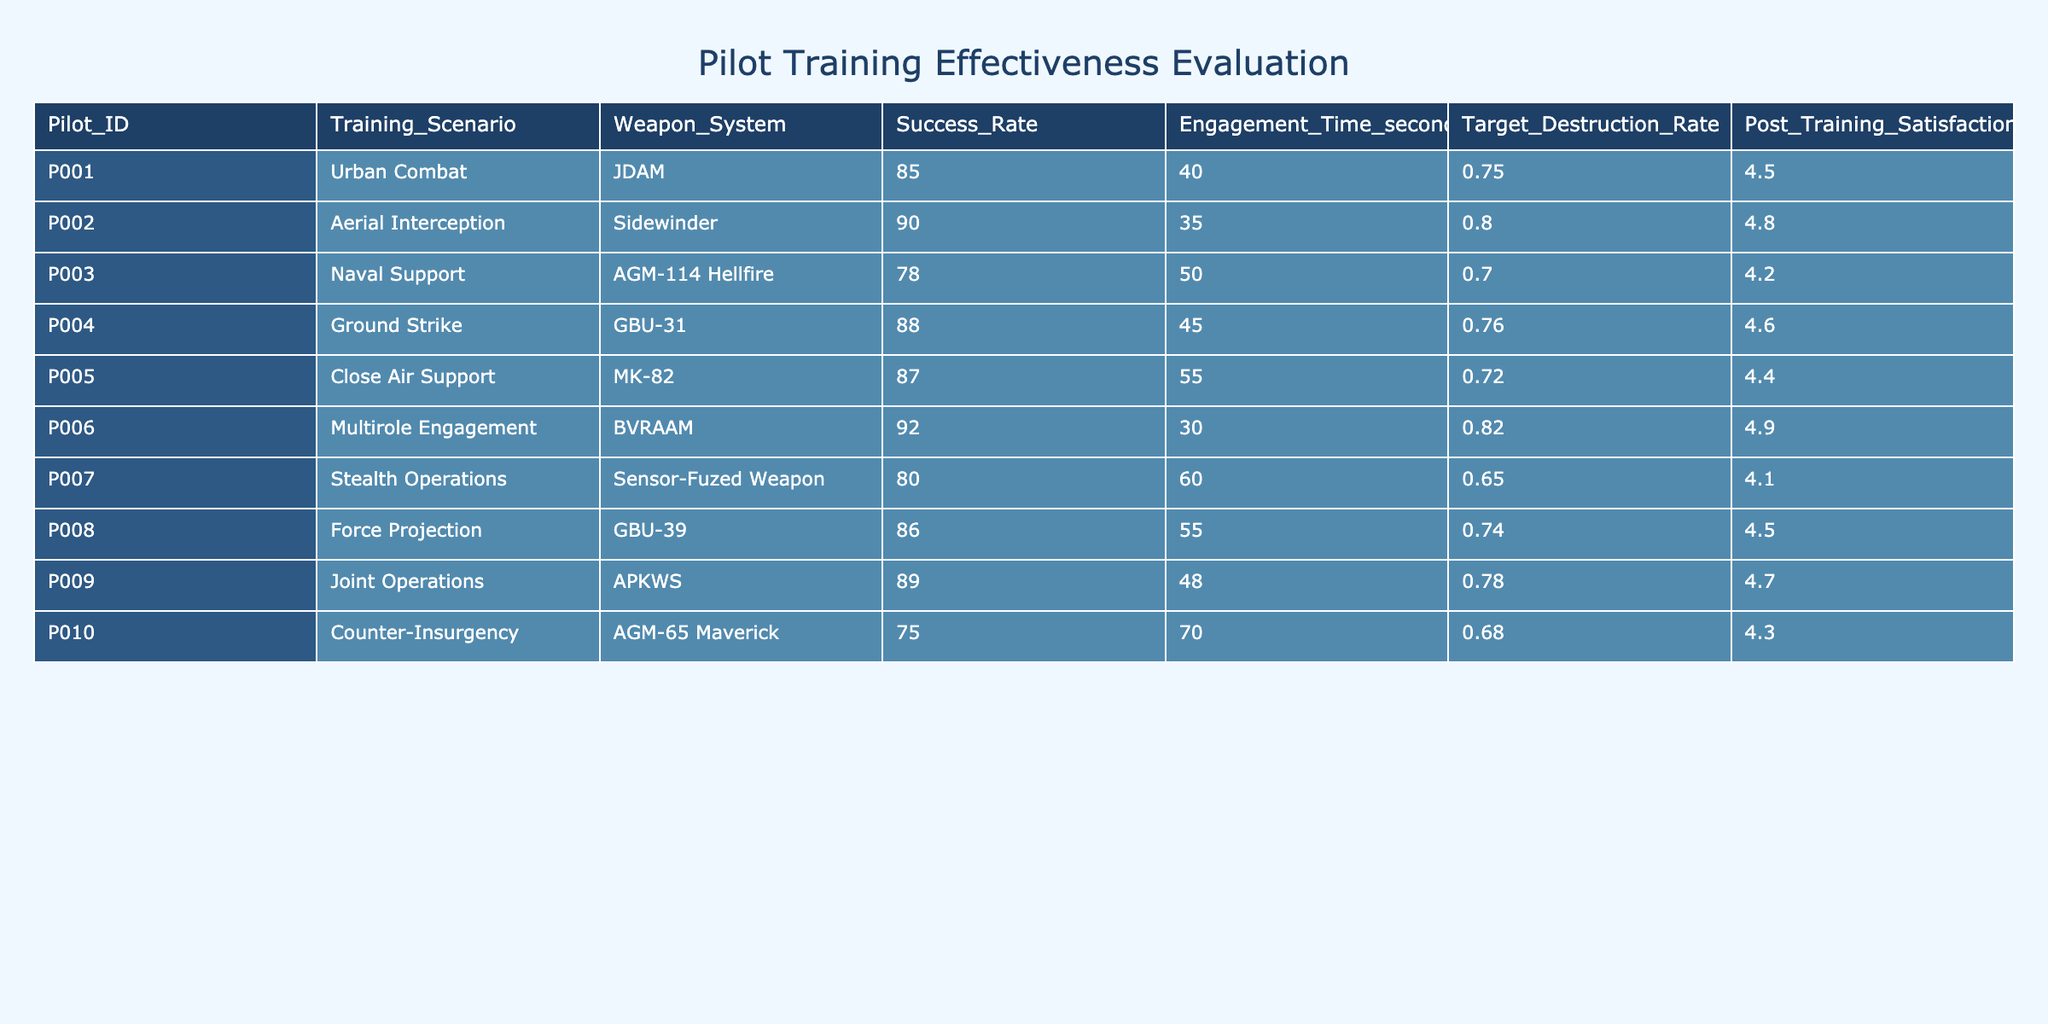What is the success rate of pilot P006? The success rate for pilot P006 can be found by locating the corresponding row in the table. P006 has a success rate of 92.
Answer: 92 Which pilot had the highest post-training satisfaction score? To find the highest post-training satisfaction score, we need to look at the 'Post_Training_Satisfaction_Score' column and identify the maximum value. The maximum value is 4.9, which belongs to pilot P006.
Answer: 4.9 What is the average engagement time of all pilots? First, we sum the engagement times of all pilots: 40 + 35 + 50 + 45 + 55 + 30 + 60 + 55 + 48 + 70 = 485 seconds. There are 10 pilots, so we divide by 10: 485 / 10 = 48.5 seconds.
Answer: 48.5 seconds Is the target destruction rate of pilot P010 higher than that of pilot P003? We need to compare the target destruction rates of both pilots. P010 has a target destruction rate of 0.68, while P003 has a rate of 0.70. Since 0.68 is not greater than 0.70, the answer is no.
Answer: No What is the difference in success rates between pilots P002 and P007? For pilot P002, the success rate is 90, and for pilot P007, it is 80. The difference is calculated as 90 - 80 = 10.
Answer: 10 